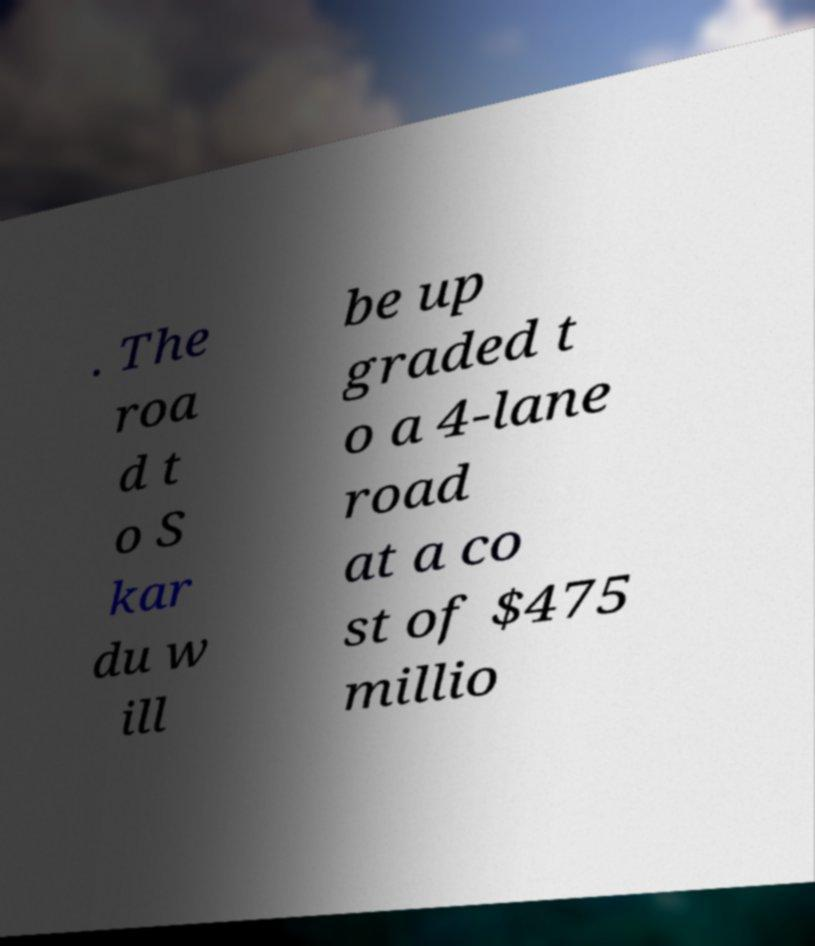For documentation purposes, I need the text within this image transcribed. Could you provide that? . The roa d t o S kar du w ill be up graded t o a 4-lane road at a co st of $475 millio 